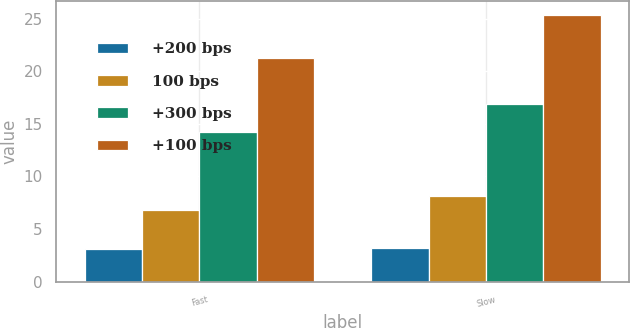Convert chart to OTSL. <chart><loc_0><loc_0><loc_500><loc_500><stacked_bar_chart><ecel><fcel>Fast<fcel>Slow<nl><fcel>+200 bps<fcel>3.1<fcel>3.2<nl><fcel>100 bps<fcel>6.8<fcel>8.1<nl><fcel>+300 bps<fcel>14.2<fcel>16.9<nl><fcel>+100 bps<fcel>21.3<fcel>25.4<nl></chart> 